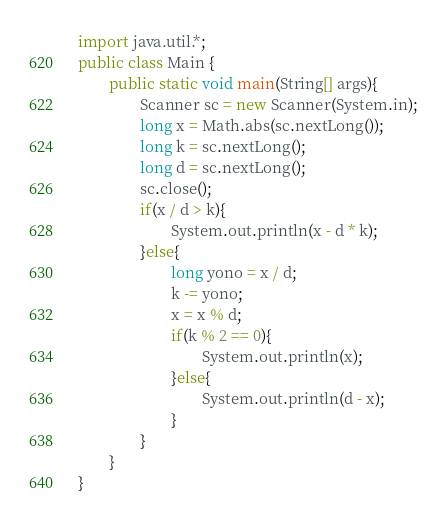Convert code to text. <code><loc_0><loc_0><loc_500><loc_500><_Java_>import java.util.*;
public class Main {
        public static void main(String[] args){
                Scanner sc = new Scanner(System.in);
                long x = Math.abs(sc.nextLong());
                long k = sc.nextLong();
                long d = sc.nextLong();
                sc.close();
                if(x / d > k){
                        System.out.println(x - d * k);
                }else{
                        long yono = x / d;
                        k -= yono;
                        x = x % d;
                        if(k % 2 == 0){
                                System.out.println(x);
                        }else{
                                System.out.println(d - x);
                        }
                }
        }
}</code> 